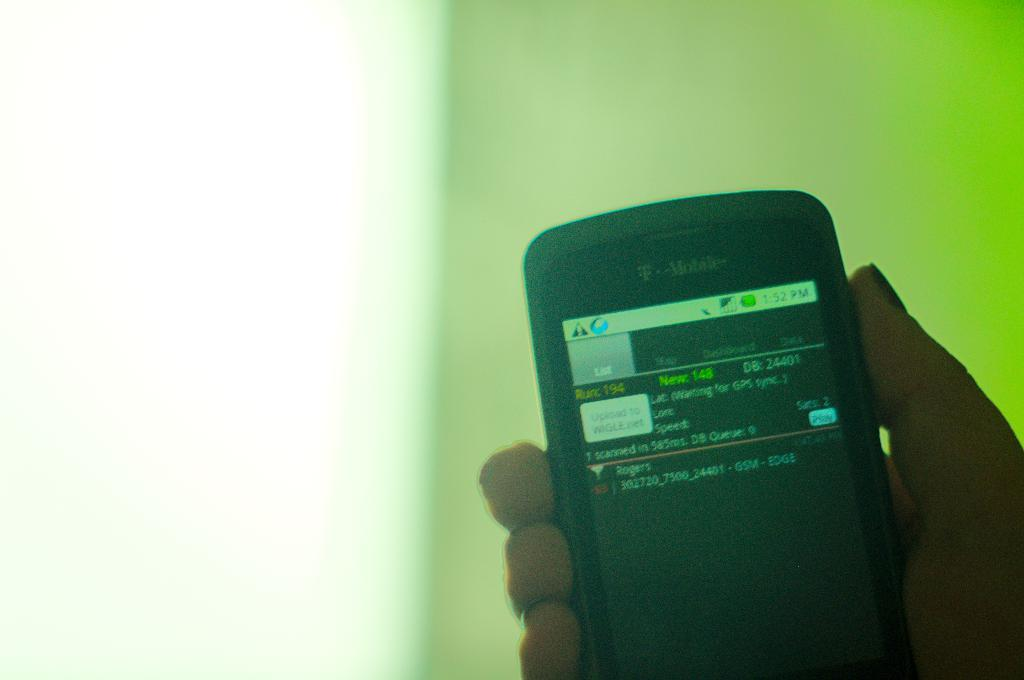What part of the body is visible in the image? There is a person's hand in the image. What is the hand holding? The hand is holding a mobile. Where is the hand and mobile located in the image? The hand and mobile are in the center of the image. What type of lunch is being prepared in the image? There is no lunch preparation visible in the image; it only shows a person's hand holding a mobile. 